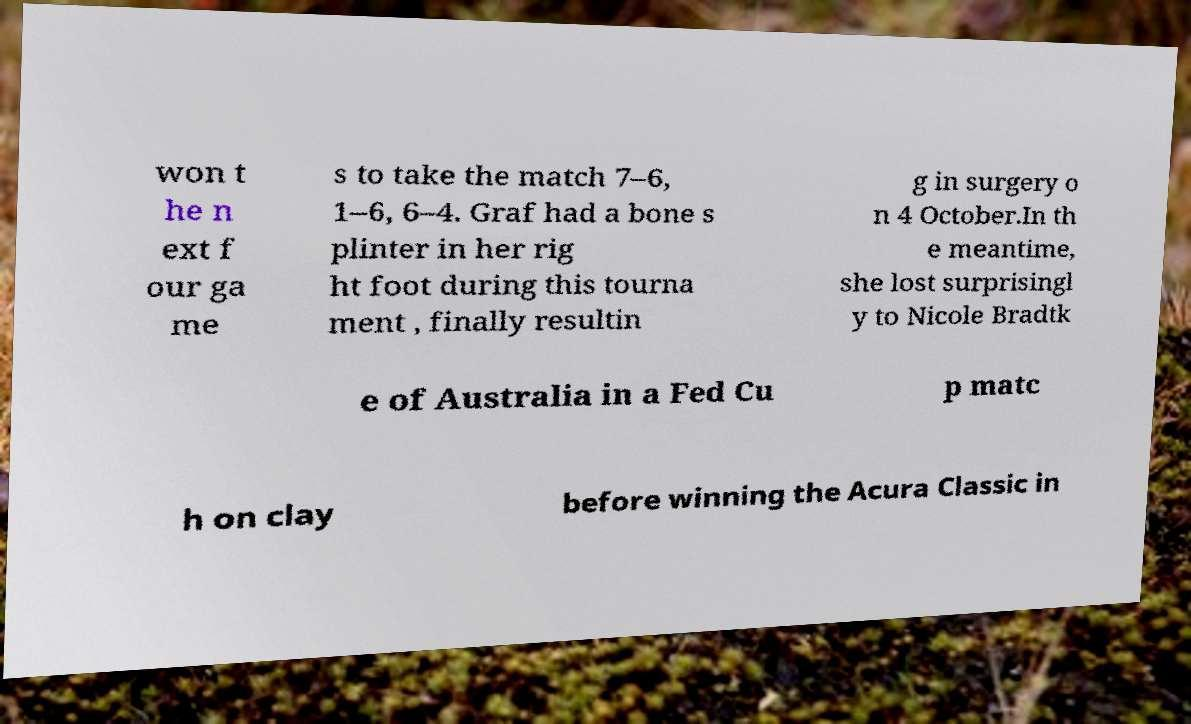There's text embedded in this image that I need extracted. Can you transcribe it verbatim? won t he n ext f our ga me s to take the match 7–6, 1–6, 6–4. Graf had a bone s plinter in her rig ht foot during this tourna ment , finally resultin g in surgery o n 4 October.In th e meantime, she lost surprisingl y to Nicole Bradtk e of Australia in a Fed Cu p matc h on clay before winning the Acura Classic in 